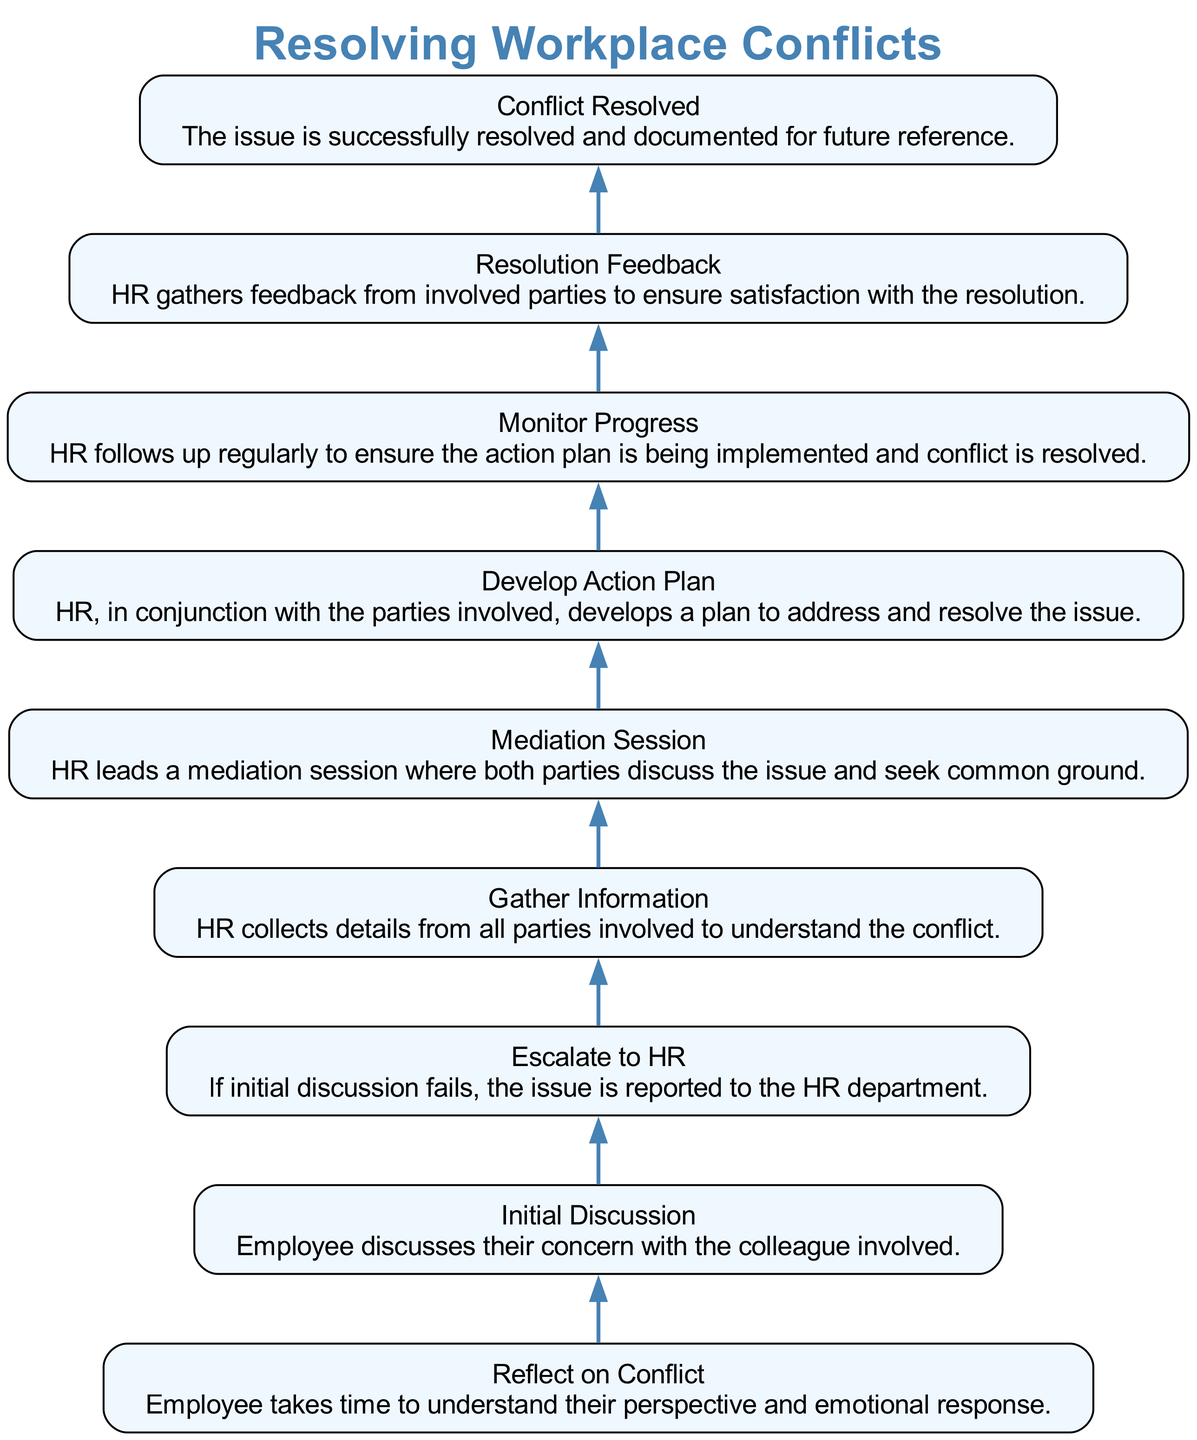What is the first step in resolving workplace conflicts? The diagram lists "Reflect on Conflict" as the first step. It is the first node at the bottom of the flow.
Answer: Reflect on Conflict How many total steps are there in the conflict resolution process? By counting the nodes presented in the diagram, there are nine steps in total.
Answer: 9 What follows the "Initial Discussion" step? The diagram shows that "Escalate to HR" directly follows the "Initial Discussion" node, indicating the next action if the discussion does not resolve the conflict.
Answer: Escalate to HR What is the purpose of the "Gather Information" step? This step involves HR collecting details from all parties to understand the conflict, as described in the node.
Answer: To understand the conflict Which step comes before "Conflict Resolved"? The diagram shows "Resolution Feedback" as the step immediately preceding "Conflict Resolved," indicating the final steps before resolution.
Answer: Resolution Feedback What is the last step in the flow? The last node at the top of the diagram indicates that the process culminates in "Conflict Resolved."
Answer: Conflict Resolved What must occur after the "Mediation Session"? After the mediation session, the next step indicated in the diagram is "Develop Action Plan," highlighting the progression in resolving the conflict.
Answer: Develop Action Plan Which steps involve HR's direct interaction? The steps "Gather Information," "Mediation Session," "Develop Action Plan," and "Monitor Progress" explicitly mention HR's involvement, reflecting critical roles in the process.
Answer: Gather Information, Mediation Session, Develop Action Plan, Monitor Progress What is the purpose of the "Monitor Progress" step? This step aims to ensure the action plan is being implemented and to confirm that the conflict resolution is effective by following up with involved parties.
Answer: To ensure action plan implementation 